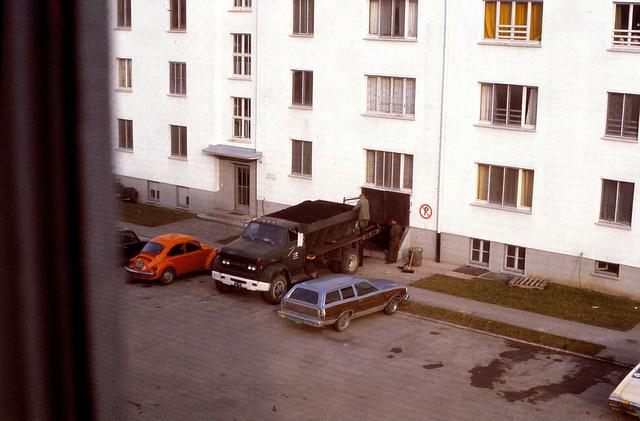Why is the truck backed up to the building? Please explain your reasoning. loading. The trunk is put close the the entrance and there is an object on the trunk bed of the truck. a person seems to have moved something onto it. 